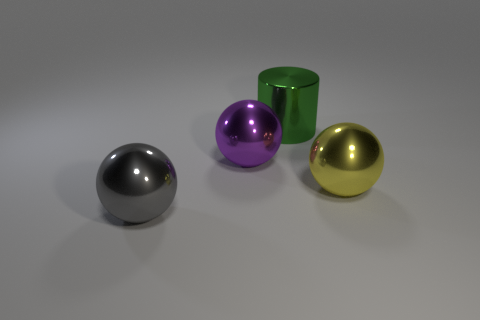Add 2 purple balls. How many objects exist? 6 Subtract all yellow balls. How many balls are left? 2 Subtract all yellow balls. How many balls are left? 2 Subtract all balls. How many objects are left? 1 Subtract 3 balls. How many balls are left? 0 Subtract 0 gray cubes. How many objects are left? 4 Subtract all cyan balls. Subtract all cyan cylinders. How many balls are left? 3 Subtract all large gray things. Subtract all gray metal balls. How many objects are left? 2 Add 1 metallic objects. How many metallic objects are left? 5 Add 4 large green metallic objects. How many large green metallic objects exist? 5 